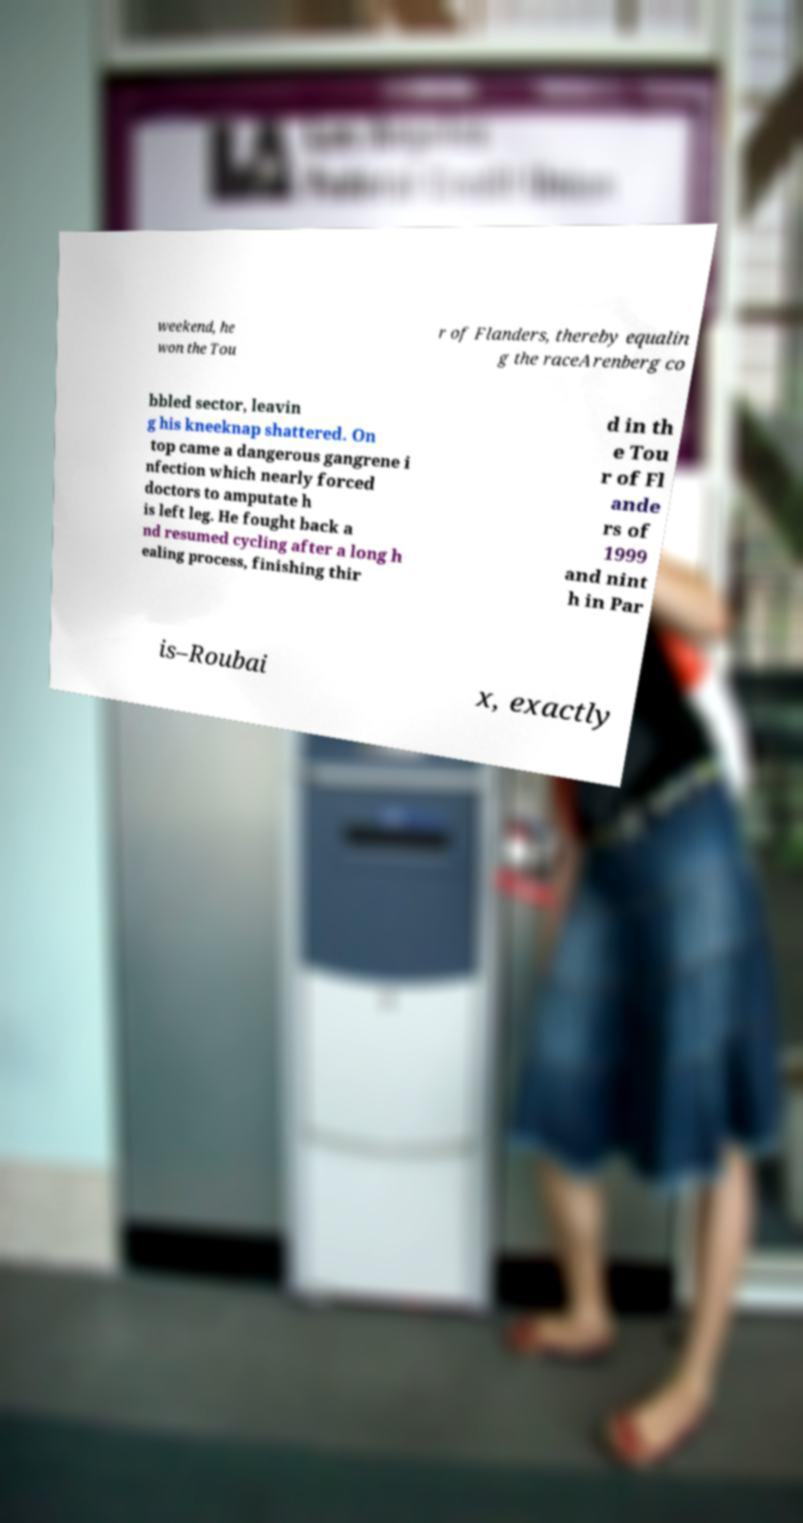For documentation purposes, I need the text within this image transcribed. Could you provide that? weekend, he won the Tou r of Flanders, thereby equalin g the raceArenberg co bbled sector, leavin g his kneeknap shattered. On top came a dangerous gangrene i nfection which nearly forced doctors to amputate h is left leg. He fought back a nd resumed cycling after a long h ealing process, finishing thir d in th e Tou r of Fl ande rs of 1999 and nint h in Par is–Roubai x, exactly 